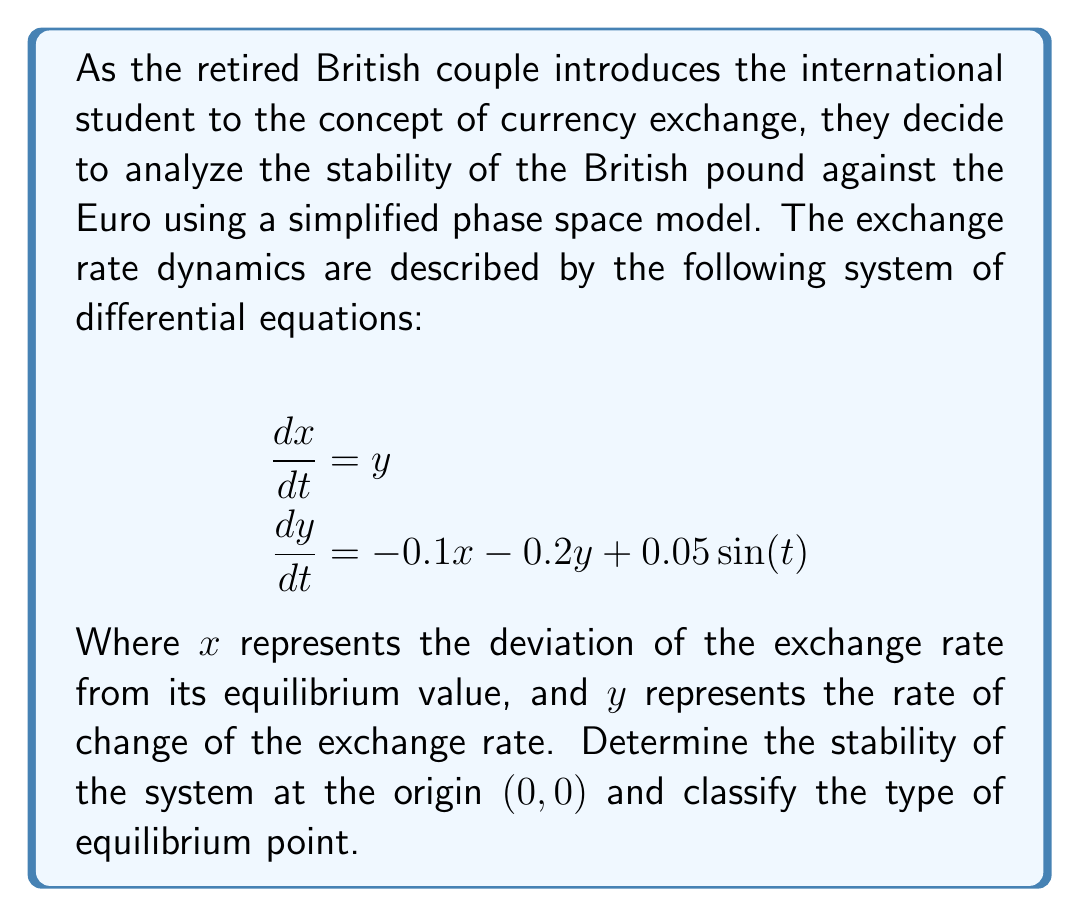What is the answer to this math problem? To analyze the stability of the system at the origin, we follow these steps:

1. Identify the linearized system:
   The system is already linear except for the small periodic term $0.05\sin(t)$. We can ignore this term for local stability analysis.

2. Write the system in matrix form:
   $$\begin{pmatrix} \dot{x} \\ \dot{y} \end{pmatrix} = \begin{pmatrix} 0 & 1 \\ -0.1 & -0.2 \end{pmatrix} \begin{pmatrix} x \\ y \end{pmatrix}$$

3. Calculate the eigenvalues:
   The characteristic equation is:
   $$\det(\lambda I - A) = \lambda^2 + 0.2\lambda + 0.1 = 0$$
   
   Using the quadratic formula:
   $$\lambda = \frac{-0.2 \pm \sqrt{0.04 - 0.4}}{2} = -0.1 \pm 0.3i$$

4. Analyze the eigenvalues:
   The real part of both eigenvalues is negative (-0.1), and there is a non-zero imaginary part (±0.3i).

5. Classify the equilibrium point:
   Negative real parts indicate that the origin is asymptotically stable.
   The presence of imaginary parts indicates oscillatory behavior.
   
Therefore, the origin (0,0) is a stable focus (spiral sink). The exchange rate will oscillate with decreasing amplitude, eventually converging to the equilibrium value.
Answer: Stable focus (spiral sink) 